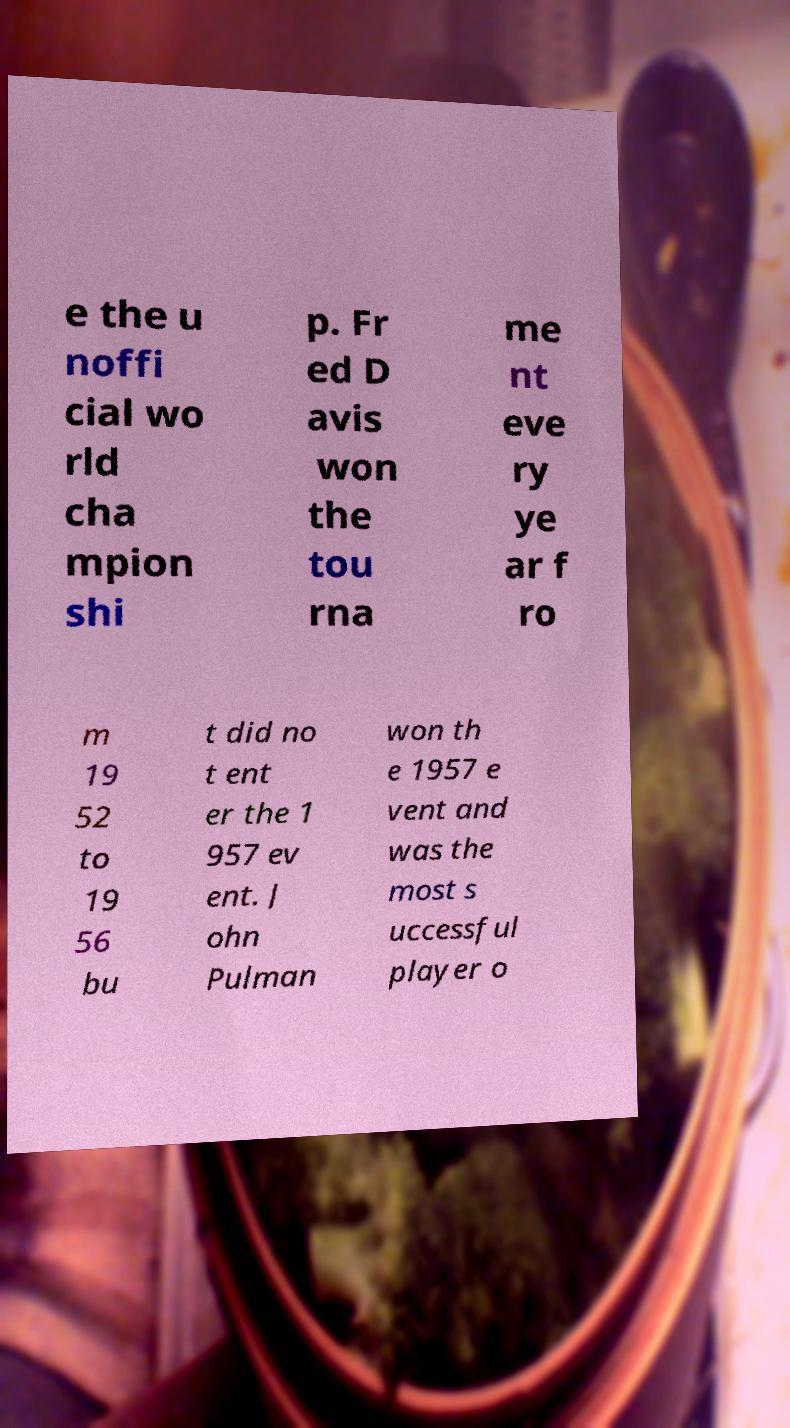There's text embedded in this image that I need extracted. Can you transcribe it verbatim? e the u noffi cial wo rld cha mpion shi p. Fr ed D avis won the tou rna me nt eve ry ye ar f ro m 19 52 to 19 56 bu t did no t ent er the 1 957 ev ent. J ohn Pulman won th e 1957 e vent and was the most s uccessful player o 